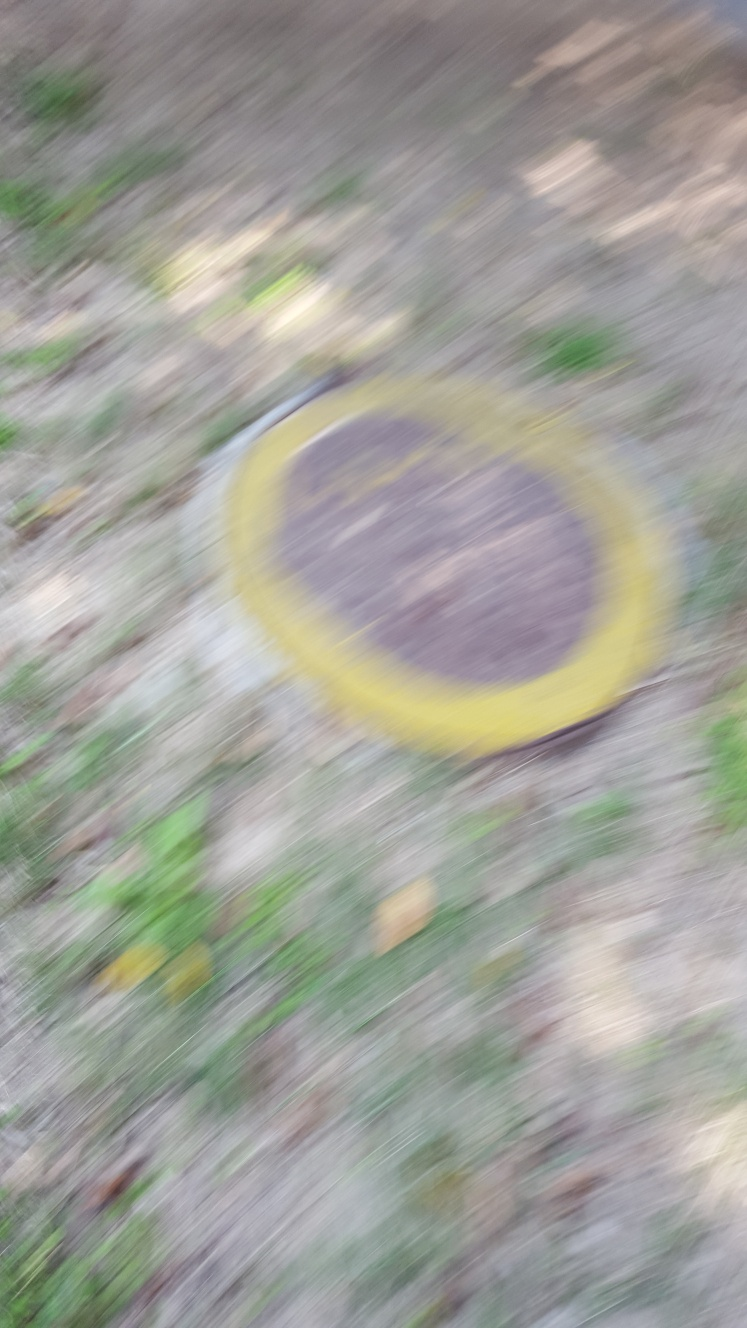What is the resolution of this photo?
A. high
B. low
C. unknown
D. medium Based on the visible blur and lack of clear details, the quality of the image appears to be low. Therefore, the most accurate answer to the question is B. low. The image does not have sharp details which are usually indicative of a high-resolution photo. 